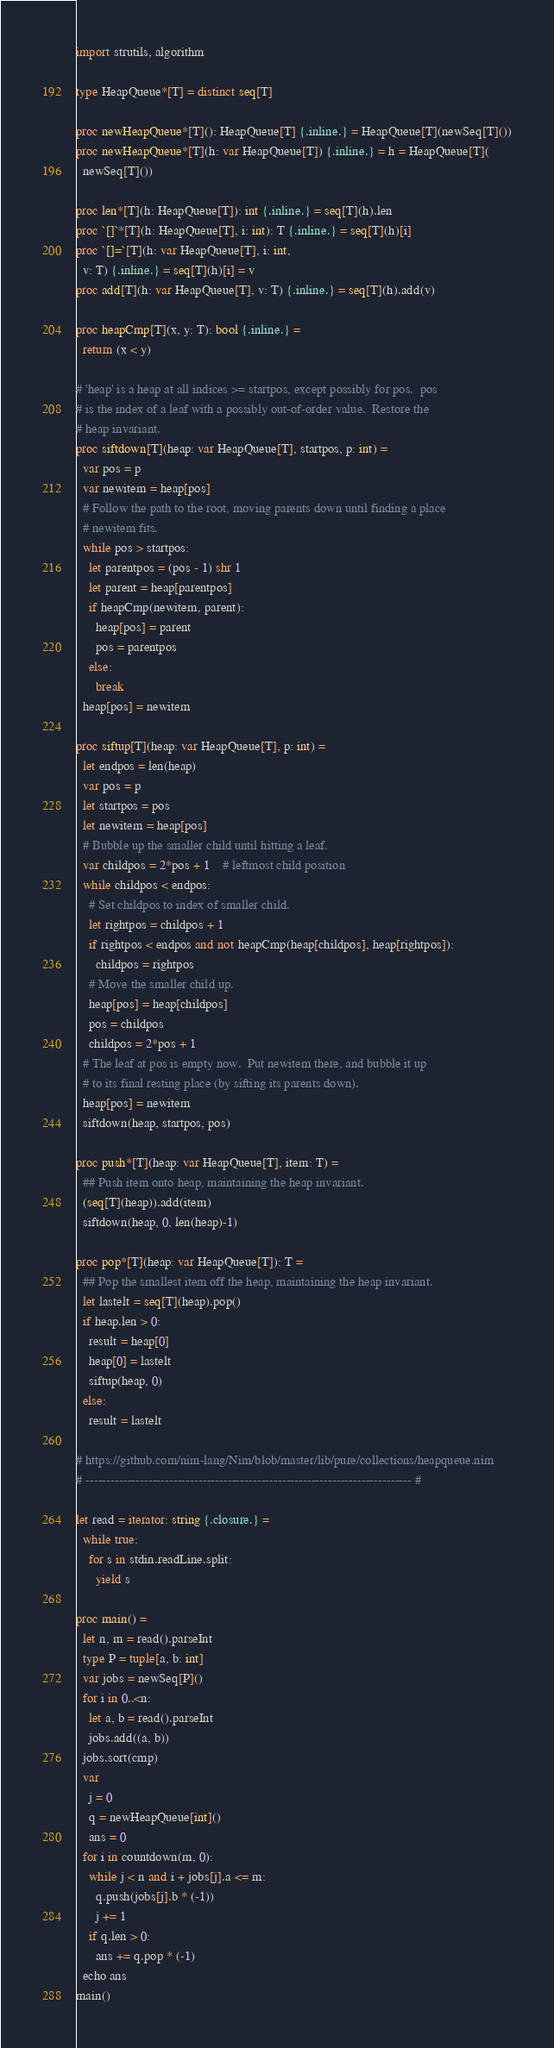Convert code to text. <code><loc_0><loc_0><loc_500><loc_500><_Nim_>import strutils, algorithm

type HeapQueue*[T] = distinct seq[T]

proc newHeapQueue*[T](): HeapQueue[T] {.inline.} = HeapQueue[T](newSeq[T]())
proc newHeapQueue*[T](h: var HeapQueue[T]) {.inline.} = h = HeapQueue[T](
  newSeq[T]())

proc len*[T](h: HeapQueue[T]): int {.inline.} = seq[T](h).len
proc `[]`*[T](h: HeapQueue[T], i: int): T {.inline.} = seq[T](h)[i]
proc `[]=`[T](h: var HeapQueue[T], i: int,
  v: T) {.inline.} = seq[T](h)[i] = v
proc add[T](h: var HeapQueue[T], v: T) {.inline.} = seq[T](h).add(v)

proc heapCmp[T](x, y: T): bool {.inline.} =
  return (x < y)

# 'heap' is a heap at all indices >= startpos, except possibly for pos.  pos
# is the index of a leaf with a possibly out-of-order value.  Restore the
# heap invariant.
proc siftdown[T](heap: var HeapQueue[T], startpos, p: int) =
  var pos = p
  var newitem = heap[pos]
  # Follow the path to the root, moving parents down until finding a place
  # newitem fits.
  while pos > startpos:
    let parentpos = (pos - 1) shr 1
    let parent = heap[parentpos]
    if heapCmp(newitem, parent):
      heap[pos] = parent
      pos = parentpos
    else:
      break
  heap[pos] = newitem

proc siftup[T](heap: var HeapQueue[T], p: int) =
  let endpos = len(heap)
  var pos = p
  let startpos = pos
  let newitem = heap[pos]
  # Bubble up the smaller child until hitting a leaf.
  var childpos = 2*pos + 1    # leftmost child position
  while childpos < endpos:
    # Set childpos to index of smaller child.
    let rightpos = childpos + 1
    if rightpos < endpos and not heapCmp(heap[childpos], heap[rightpos]):
      childpos = rightpos
    # Move the smaller child up.
    heap[pos] = heap[childpos]
    pos = childpos
    childpos = 2*pos + 1
  # The leaf at pos is empty now.  Put newitem there, and bubble it up
  # to its final resting place (by sifting its parents down).
  heap[pos] = newitem
  siftdown(heap, startpos, pos)

proc push*[T](heap: var HeapQueue[T], item: T) =
  ## Push item onto heap, maintaining the heap invariant.
  (seq[T](heap)).add(item)
  siftdown(heap, 0, len(heap)-1)

proc pop*[T](heap: var HeapQueue[T]): T =
  ## Pop the smallest item off the heap, maintaining the heap invariant.
  let lastelt = seq[T](heap).pop()
  if heap.len > 0:
    result = heap[0]
    heap[0] = lastelt
    siftup(heap, 0)
  else:
    result = lastelt

# https://github.com/nim-lang/Nim/blob/master/lib/pure/collections/heapqueue.nim
# ------------------------------------------------------------------------------ #

let read = iterator: string {.closure.} =
  while true:
    for s in stdin.readLine.split:
      yield s

proc main() =
  let n, m = read().parseInt
  type P = tuple[a, b: int]
  var jobs = newSeq[P]()
  for i in 0..<n:
    let a, b = read().parseInt
    jobs.add((a, b))
  jobs.sort(cmp)
  var
    j = 0
    q = newHeapQueue[int]()
    ans = 0
  for i in countdown(m, 0):
    while j < n and i + jobs[j].a <= m:
      q.push(jobs[j].b * (-1))
      j += 1
    if q.len > 0:
      ans += q.pop * (-1)
  echo ans
main()</code> 